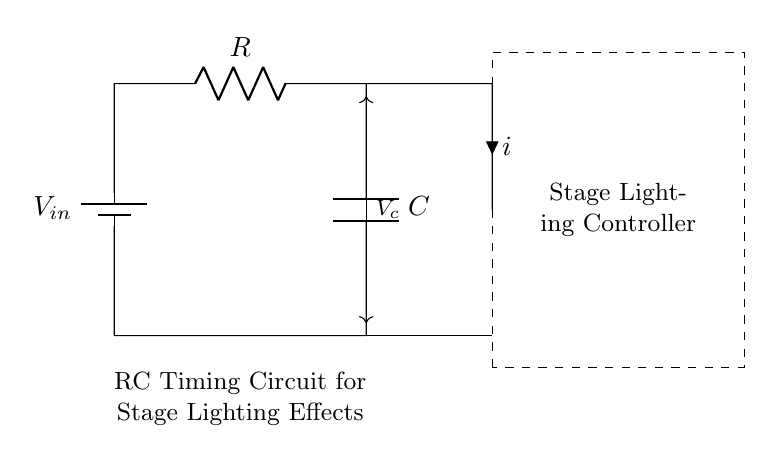What is the power source in this circuit? The power source is labeled V_in, indicating the input voltage from the battery.
Answer: V_in What component is responsible for storing energy? The component that stores energy in this circuit is the capacitor, which is represented as C.
Answer: C What is the function of the resistor? The resistor R controls the charging and discharging rates of the voltage across the capacitor, affecting the timing characteristics.
Answer: R What is the relationship between the resistor and capacitor in this circuit? The resistor and capacitor form an RC timing circuit, where the resistor determines the charge and discharge time constant, denoted by the formula τ = R x C.
Answer: RC timing circuit What would happen if the resistance is increased? Increasing the resistance R would increase the time constant τ, resulting in a longer time for the capacitor to charge and discharge, thus extending the timing interval for the stage lighting effects.
Answer: Longer timing interval What does V_c represent in this circuit? V_c represents the voltage across the capacitor, which varies over time as the capacitor charges and discharges, and is crucial in determining the timing effect for the stage lighting.
Answer: Voltage across capacitor 